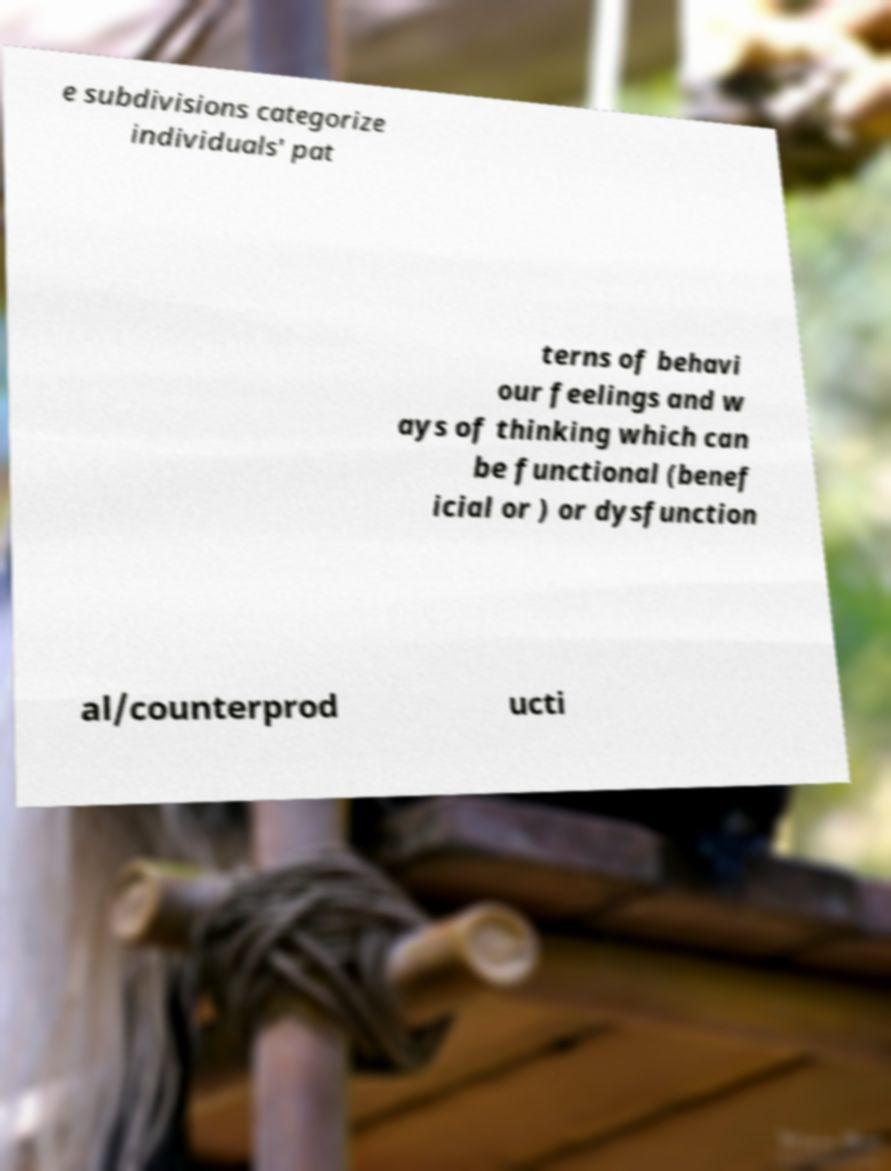Can you read and provide the text displayed in the image?This photo seems to have some interesting text. Can you extract and type it out for me? e subdivisions categorize individuals' pat terns of behavi our feelings and w ays of thinking which can be functional (benef icial or ) or dysfunction al/counterprod ucti 